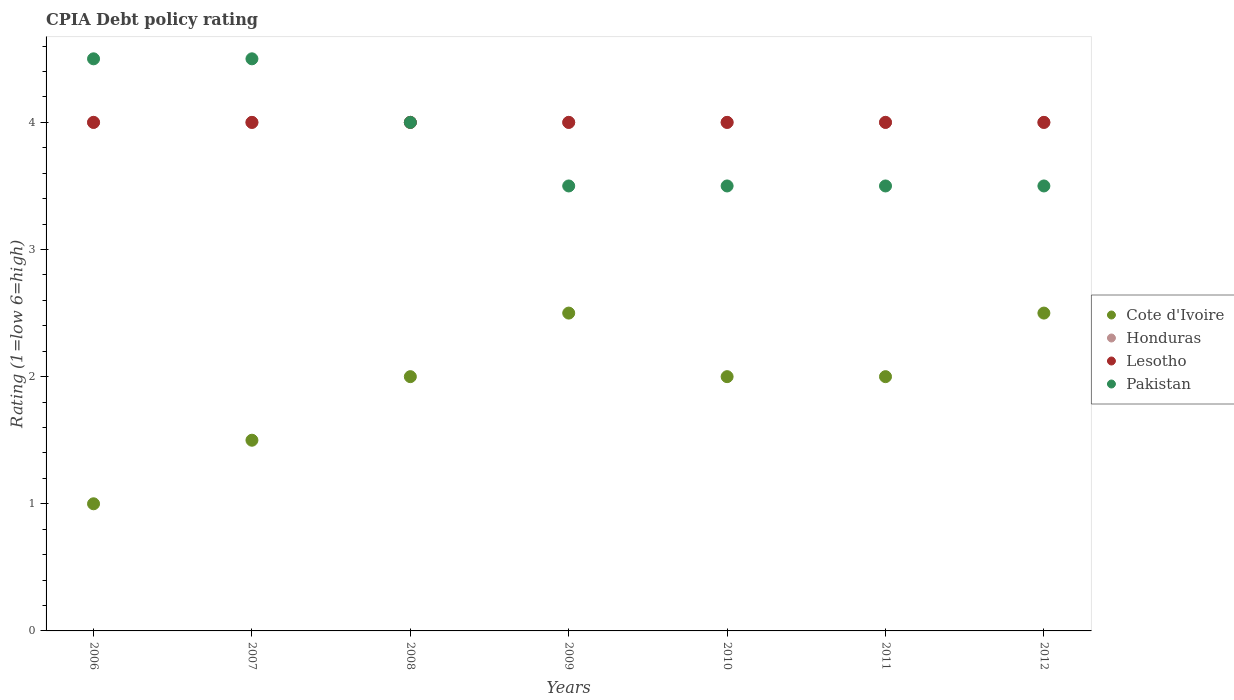What is the CPIA rating in Pakistan in 2009?
Your answer should be very brief. 3.5. Across all years, what is the maximum CPIA rating in Lesotho?
Keep it short and to the point. 4. Across all years, what is the minimum CPIA rating in Lesotho?
Offer a very short reply. 4. In which year was the CPIA rating in Pakistan minimum?
Give a very brief answer. 2009. What is the total CPIA rating in Honduras in the graph?
Your answer should be compact. 28. What is the difference between the CPIA rating in Lesotho in 2009 and that in 2010?
Offer a very short reply. 0. What is the difference between the CPIA rating in Cote d'Ivoire in 2010 and the CPIA rating in Pakistan in 2007?
Offer a terse response. -2.5. In the year 2007, what is the difference between the CPIA rating in Cote d'Ivoire and CPIA rating in Pakistan?
Keep it short and to the point. -3. What is the ratio of the CPIA rating in Cote d'Ivoire in 2006 to that in 2012?
Ensure brevity in your answer.  0.4. What is the difference between the highest and the lowest CPIA rating in Honduras?
Provide a short and direct response. 0. Is it the case that in every year, the sum of the CPIA rating in Honduras and CPIA rating in Lesotho  is greater than the sum of CPIA rating in Cote d'Ivoire and CPIA rating in Pakistan?
Your answer should be very brief. No. Is it the case that in every year, the sum of the CPIA rating in Honduras and CPIA rating in Pakistan  is greater than the CPIA rating in Cote d'Ivoire?
Provide a succinct answer. Yes. Does the CPIA rating in Pakistan monotonically increase over the years?
Offer a terse response. No. Is the CPIA rating in Pakistan strictly less than the CPIA rating in Cote d'Ivoire over the years?
Keep it short and to the point. No. How many years are there in the graph?
Provide a succinct answer. 7. Does the graph contain any zero values?
Provide a short and direct response. No. How are the legend labels stacked?
Your response must be concise. Vertical. What is the title of the graph?
Provide a succinct answer. CPIA Debt policy rating. Does "Cambodia" appear as one of the legend labels in the graph?
Give a very brief answer. No. What is the label or title of the X-axis?
Ensure brevity in your answer.  Years. What is the label or title of the Y-axis?
Provide a succinct answer. Rating (1=low 6=high). What is the Rating (1=low 6=high) of Honduras in 2008?
Offer a very short reply. 4. What is the Rating (1=low 6=high) of Lesotho in 2008?
Your response must be concise. 4. What is the Rating (1=low 6=high) of Pakistan in 2008?
Your answer should be compact. 4. What is the Rating (1=low 6=high) in Cote d'Ivoire in 2009?
Your response must be concise. 2.5. What is the Rating (1=low 6=high) in Honduras in 2009?
Keep it short and to the point. 4. What is the Rating (1=low 6=high) in Pakistan in 2009?
Ensure brevity in your answer.  3.5. What is the Rating (1=low 6=high) in Cote d'Ivoire in 2010?
Provide a succinct answer. 2. What is the Rating (1=low 6=high) in Honduras in 2010?
Provide a short and direct response. 4. What is the Rating (1=low 6=high) in Pakistan in 2010?
Make the answer very short. 3.5. What is the Rating (1=low 6=high) of Cote d'Ivoire in 2011?
Offer a terse response. 2. What is the Rating (1=low 6=high) in Honduras in 2011?
Make the answer very short. 4. What is the Rating (1=low 6=high) in Lesotho in 2012?
Provide a succinct answer. 4. What is the Rating (1=low 6=high) of Pakistan in 2012?
Your answer should be compact. 3.5. Across all years, what is the maximum Rating (1=low 6=high) in Cote d'Ivoire?
Your answer should be very brief. 2.5. Across all years, what is the maximum Rating (1=low 6=high) in Pakistan?
Provide a succinct answer. 4.5. What is the total Rating (1=low 6=high) in Lesotho in the graph?
Keep it short and to the point. 28. What is the difference between the Rating (1=low 6=high) in Cote d'Ivoire in 2006 and that in 2007?
Provide a succinct answer. -0.5. What is the difference between the Rating (1=low 6=high) of Lesotho in 2006 and that in 2007?
Ensure brevity in your answer.  0. What is the difference between the Rating (1=low 6=high) of Cote d'Ivoire in 2006 and that in 2008?
Offer a terse response. -1. What is the difference between the Rating (1=low 6=high) in Honduras in 2006 and that in 2008?
Provide a succinct answer. 0. What is the difference between the Rating (1=low 6=high) in Cote d'Ivoire in 2006 and that in 2009?
Your answer should be very brief. -1.5. What is the difference between the Rating (1=low 6=high) of Honduras in 2006 and that in 2009?
Make the answer very short. 0. What is the difference between the Rating (1=low 6=high) of Lesotho in 2006 and that in 2009?
Your answer should be very brief. 0. What is the difference between the Rating (1=low 6=high) in Pakistan in 2006 and that in 2009?
Provide a succinct answer. 1. What is the difference between the Rating (1=low 6=high) of Cote d'Ivoire in 2006 and that in 2010?
Your answer should be very brief. -1. What is the difference between the Rating (1=low 6=high) of Honduras in 2006 and that in 2010?
Provide a succinct answer. 0. What is the difference between the Rating (1=low 6=high) of Lesotho in 2006 and that in 2010?
Give a very brief answer. 0. What is the difference between the Rating (1=low 6=high) of Pakistan in 2006 and that in 2010?
Ensure brevity in your answer.  1. What is the difference between the Rating (1=low 6=high) of Lesotho in 2006 and that in 2011?
Provide a short and direct response. 0. What is the difference between the Rating (1=low 6=high) of Honduras in 2006 and that in 2012?
Offer a terse response. 0. What is the difference between the Rating (1=low 6=high) of Pakistan in 2006 and that in 2012?
Offer a very short reply. 1. What is the difference between the Rating (1=low 6=high) of Cote d'Ivoire in 2007 and that in 2008?
Provide a succinct answer. -0.5. What is the difference between the Rating (1=low 6=high) of Honduras in 2007 and that in 2009?
Your answer should be compact. 0. What is the difference between the Rating (1=low 6=high) in Pakistan in 2007 and that in 2010?
Give a very brief answer. 1. What is the difference between the Rating (1=low 6=high) in Pakistan in 2007 and that in 2011?
Keep it short and to the point. 1. What is the difference between the Rating (1=low 6=high) in Honduras in 2007 and that in 2012?
Give a very brief answer. 0. What is the difference between the Rating (1=low 6=high) in Lesotho in 2007 and that in 2012?
Give a very brief answer. 0. What is the difference between the Rating (1=low 6=high) in Pakistan in 2007 and that in 2012?
Make the answer very short. 1. What is the difference between the Rating (1=low 6=high) of Honduras in 2008 and that in 2009?
Provide a succinct answer. 0. What is the difference between the Rating (1=low 6=high) of Lesotho in 2008 and that in 2009?
Give a very brief answer. 0. What is the difference between the Rating (1=low 6=high) of Pakistan in 2008 and that in 2009?
Offer a very short reply. 0.5. What is the difference between the Rating (1=low 6=high) of Cote d'Ivoire in 2008 and that in 2010?
Provide a short and direct response. 0. What is the difference between the Rating (1=low 6=high) of Honduras in 2008 and that in 2010?
Your answer should be compact. 0. What is the difference between the Rating (1=low 6=high) of Lesotho in 2008 and that in 2011?
Make the answer very short. 0. What is the difference between the Rating (1=low 6=high) of Cote d'Ivoire in 2008 and that in 2012?
Give a very brief answer. -0.5. What is the difference between the Rating (1=low 6=high) of Lesotho in 2008 and that in 2012?
Provide a short and direct response. 0. What is the difference between the Rating (1=low 6=high) in Cote d'Ivoire in 2009 and that in 2010?
Ensure brevity in your answer.  0.5. What is the difference between the Rating (1=low 6=high) in Lesotho in 2009 and that in 2011?
Provide a succinct answer. 0. What is the difference between the Rating (1=low 6=high) of Cote d'Ivoire in 2009 and that in 2012?
Provide a succinct answer. 0. What is the difference between the Rating (1=low 6=high) in Pakistan in 2009 and that in 2012?
Provide a succinct answer. 0. What is the difference between the Rating (1=low 6=high) of Honduras in 2010 and that in 2011?
Give a very brief answer. 0. What is the difference between the Rating (1=low 6=high) in Pakistan in 2010 and that in 2011?
Offer a very short reply. 0. What is the difference between the Rating (1=low 6=high) in Cote d'Ivoire in 2010 and that in 2012?
Offer a terse response. -0.5. What is the difference between the Rating (1=low 6=high) in Honduras in 2011 and that in 2012?
Provide a succinct answer. 0. What is the difference between the Rating (1=low 6=high) in Lesotho in 2011 and that in 2012?
Make the answer very short. 0. What is the difference between the Rating (1=low 6=high) of Cote d'Ivoire in 2006 and the Rating (1=low 6=high) of Pakistan in 2007?
Provide a short and direct response. -3.5. What is the difference between the Rating (1=low 6=high) of Lesotho in 2006 and the Rating (1=low 6=high) of Pakistan in 2007?
Your answer should be compact. -0.5. What is the difference between the Rating (1=low 6=high) in Cote d'Ivoire in 2006 and the Rating (1=low 6=high) in Honduras in 2008?
Provide a succinct answer. -3. What is the difference between the Rating (1=low 6=high) of Honduras in 2006 and the Rating (1=low 6=high) of Pakistan in 2008?
Ensure brevity in your answer.  0. What is the difference between the Rating (1=low 6=high) of Lesotho in 2006 and the Rating (1=low 6=high) of Pakistan in 2008?
Provide a short and direct response. 0. What is the difference between the Rating (1=low 6=high) of Cote d'Ivoire in 2006 and the Rating (1=low 6=high) of Honduras in 2009?
Give a very brief answer. -3. What is the difference between the Rating (1=low 6=high) in Cote d'Ivoire in 2006 and the Rating (1=low 6=high) in Pakistan in 2009?
Your answer should be very brief. -2.5. What is the difference between the Rating (1=low 6=high) of Honduras in 2006 and the Rating (1=low 6=high) of Pakistan in 2009?
Offer a very short reply. 0.5. What is the difference between the Rating (1=low 6=high) in Lesotho in 2006 and the Rating (1=low 6=high) in Pakistan in 2009?
Make the answer very short. 0.5. What is the difference between the Rating (1=low 6=high) of Cote d'Ivoire in 2006 and the Rating (1=low 6=high) of Honduras in 2010?
Your response must be concise. -3. What is the difference between the Rating (1=low 6=high) in Cote d'Ivoire in 2006 and the Rating (1=low 6=high) in Pakistan in 2010?
Your answer should be compact. -2.5. What is the difference between the Rating (1=low 6=high) of Honduras in 2006 and the Rating (1=low 6=high) of Lesotho in 2010?
Your answer should be compact. 0. What is the difference between the Rating (1=low 6=high) of Honduras in 2006 and the Rating (1=low 6=high) of Pakistan in 2010?
Your answer should be compact. 0.5. What is the difference between the Rating (1=low 6=high) of Lesotho in 2006 and the Rating (1=low 6=high) of Pakistan in 2010?
Provide a succinct answer. 0.5. What is the difference between the Rating (1=low 6=high) in Cote d'Ivoire in 2006 and the Rating (1=low 6=high) in Honduras in 2011?
Offer a terse response. -3. What is the difference between the Rating (1=low 6=high) in Honduras in 2006 and the Rating (1=low 6=high) in Lesotho in 2011?
Keep it short and to the point. 0. What is the difference between the Rating (1=low 6=high) of Honduras in 2006 and the Rating (1=low 6=high) of Pakistan in 2011?
Provide a succinct answer. 0.5. What is the difference between the Rating (1=low 6=high) of Lesotho in 2006 and the Rating (1=low 6=high) of Pakistan in 2011?
Ensure brevity in your answer.  0.5. What is the difference between the Rating (1=low 6=high) of Cote d'Ivoire in 2006 and the Rating (1=low 6=high) of Honduras in 2012?
Your response must be concise. -3. What is the difference between the Rating (1=low 6=high) in Cote d'Ivoire in 2006 and the Rating (1=low 6=high) in Lesotho in 2012?
Keep it short and to the point. -3. What is the difference between the Rating (1=low 6=high) in Honduras in 2006 and the Rating (1=low 6=high) in Lesotho in 2012?
Provide a short and direct response. 0. What is the difference between the Rating (1=low 6=high) of Honduras in 2006 and the Rating (1=low 6=high) of Pakistan in 2012?
Provide a short and direct response. 0.5. What is the difference between the Rating (1=low 6=high) of Lesotho in 2006 and the Rating (1=low 6=high) of Pakistan in 2012?
Your answer should be very brief. 0.5. What is the difference between the Rating (1=low 6=high) in Cote d'Ivoire in 2007 and the Rating (1=low 6=high) in Lesotho in 2008?
Your answer should be compact. -2.5. What is the difference between the Rating (1=low 6=high) of Honduras in 2007 and the Rating (1=low 6=high) of Lesotho in 2008?
Offer a terse response. 0. What is the difference between the Rating (1=low 6=high) of Honduras in 2007 and the Rating (1=low 6=high) of Pakistan in 2008?
Offer a very short reply. 0. What is the difference between the Rating (1=low 6=high) of Honduras in 2007 and the Rating (1=low 6=high) of Lesotho in 2009?
Provide a short and direct response. 0. What is the difference between the Rating (1=low 6=high) in Lesotho in 2007 and the Rating (1=low 6=high) in Pakistan in 2009?
Give a very brief answer. 0.5. What is the difference between the Rating (1=low 6=high) in Cote d'Ivoire in 2007 and the Rating (1=low 6=high) in Lesotho in 2010?
Your response must be concise. -2.5. What is the difference between the Rating (1=low 6=high) of Cote d'Ivoire in 2007 and the Rating (1=low 6=high) of Pakistan in 2010?
Your answer should be compact. -2. What is the difference between the Rating (1=low 6=high) of Honduras in 2007 and the Rating (1=low 6=high) of Lesotho in 2010?
Provide a short and direct response. 0. What is the difference between the Rating (1=low 6=high) of Lesotho in 2007 and the Rating (1=low 6=high) of Pakistan in 2010?
Provide a succinct answer. 0.5. What is the difference between the Rating (1=low 6=high) in Cote d'Ivoire in 2007 and the Rating (1=low 6=high) in Lesotho in 2011?
Keep it short and to the point. -2.5. What is the difference between the Rating (1=low 6=high) in Cote d'Ivoire in 2007 and the Rating (1=low 6=high) in Honduras in 2012?
Your answer should be compact. -2.5. What is the difference between the Rating (1=low 6=high) in Cote d'Ivoire in 2007 and the Rating (1=low 6=high) in Lesotho in 2012?
Your answer should be very brief. -2.5. What is the difference between the Rating (1=low 6=high) in Lesotho in 2007 and the Rating (1=low 6=high) in Pakistan in 2012?
Your answer should be compact. 0.5. What is the difference between the Rating (1=low 6=high) in Cote d'Ivoire in 2008 and the Rating (1=low 6=high) in Pakistan in 2009?
Make the answer very short. -1.5. What is the difference between the Rating (1=low 6=high) in Honduras in 2008 and the Rating (1=low 6=high) in Lesotho in 2009?
Provide a short and direct response. 0. What is the difference between the Rating (1=low 6=high) of Honduras in 2008 and the Rating (1=low 6=high) of Pakistan in 2009?
Ensure brevity in your answer.  0.5. What is the difference between the Rating (1=low 6=high) in Lesotho in 2008 and the Rating (1=low 6=high) in Pakistan in 2009?
Offer a terse response. 0.5. What is the difference between the Rating (1=low 6=high) in Cote d'Ivoire in 2008 and the Rating (1=low 6=high) in Pakistan in 2010?
Your answer should be compact. -1.5. What is the difference between the Rating (1=low 6=high) of Cote d'Ivoire in 2008 and the Rating (1=low 6=high) of Lesotho in 2011?
Offer a terse response. -2. What is the difference between the Rating (1=low 6=high) of Cote d'Ivoire in 2008 and the Rating (1=low 6=high) of Pakistan in 2011?
Provide a short and direct response. -1.5. What is the difference between the Rating (1=low 6=high) of Honduras in 2008 and the Rating (1=low 6=high) of Lesotho in 2011?
Your response must be concise. 0. What is the difference between the Rating (1=low 6=high) of Honduras in 2008 and the Rating (1=low 6=high) of Pakistan in 2011?
Your response must be concise. 0.5. What is the difference between the Rating (1=low 6=high) in Cote d'Ivoire in 2009 and the Rating (1=low 6=high) in Honduras in 2010?
Provide a short and direct response. -1.5. What is the difference between the Rating (1=low 6=high) in Cote d'Ivoire in 2009 and the Rating (1=low 6=high) in Lesotho in 2010?
Provide a short and direct response. -1.5. What is the difference between the Rating (1=low 6=high) in Cote d'Ivoire in 2009 and the Rating (1=low 6=high) in Pakistan in 2010?
Make the answer very short. -1. What is the difference between the Rating (1=low 6=high) in Honduras in 2009 and the Rating (1=low 6=high) in Lesotho in 2010?
Your answer should be compact. 0. What is the difference between the Rating (1=low 6=high) of Cote d'Ivoire in 2009 and the Rating (1=low 6=high) of Honduras in 2011?
Ensure brevity in your answer.  -1.5. What is the difference between the Rating (1=low 6=high) of Cote d'Ivoire in 2009 and the Rating (1=low 6=high) of Pakistan in 2011?
Provide a succinct answer. -1. What is the difference between the Rating (1=low 6=high) of Cote d'Ivoire in 2009 and the Rating (1=low 6=high) of Honduras in 2012?
Your answer should be compact. -1.5. What is the difference between the Rating (1=low 6=high) of Cote d'Ivoire in 2009 and the Rating (1=low 6=high) of Lesotho in 2012?
Provide a short and direct response. -1.5. What is the difference between the Rating (1=low 6=high) in Honduras in 2009 and the Rating (1=low 6=high) in Lesotho in 2012?
Offer a terse response. 0. What is the difference between the Rating (1=low 6=high) in Cote d'Ivoire in 2010 and the Rating (1=low 6=high) in Lesotho in 2011?
Your answer should be compact. -2. What is the difference between the Rating (1=low 6=high) in Cote d'Ivoire in 2010 and the Rating (1=low 6=high) in Pakistan in 2011?
Your answer should be compact. -1.5. What is the difference between the Rating (1=low 6=high) in Honduras in 2010 and the Rating (1=low 6=high) in Lesotho in 2011?
Offer a terse response. 0. What is the difference between the Rating (1=low 6=high) of Honduras in 2010 and the Rating (1=low 6=high) of Pakistan in 2011?
Give a very brief answer. 0.5. What is the difference between the Rating (1=low 6=high) of Cote d'Ivoire in 2010 and the Rating (1=low 6=high) of Honduras in 2012?
Provide a succinct answer. -2. What is the difference between the Rating (1=low 6=high) in Cote d'Ivoire in 2010 and the Rating (1=low 6=high) in Lesotho in 2012?
Ensure brevity in your answer.  -2. What is the difference between the Rating (1=low 6=high) of Cote d'Ivoire in 2010 and the Rating (1=low 6=high) of Pakistan in 2012?
Your response must be concise. -1.5. What is the difference between the Rating (1=low 6=high) of Honduras in 2010 and the Rating (1=low 6=high) of Lesotho in 2012?
Your answer should be very brief. 0. What is the difference between the Rating (1=low 6=high) in Cote d'Ivoire in 2011 and the Rating (1=low 6=high) in Lesotho in 2012?
Keep it short and to the point. -2. What is the average Rating (1=low 6=high) in Cote d'Ivoire per year?
Make the answer very short. 1.93. What is the average Rating (1=low 6=high) in Honduras per year?
Your response must be concise. 4. What is the average Rating (1=low 6=high) in Lesotho per year?
Offer a very short reply. 4. What is the average Rating (1=low 6=high) of Pakistan per year?
Offer a very short reply. 3.86. In the year 2006, what is the difference between the Rating (1=low 6=high) in Cote d'Ivoire and Rating (1=low 6=high) in Honduras?
Provide a short and direct response. -3. In the year 2006, what is the difference between the Rating (1=low 6=high) of Honduras and Rating (1=low 6=high) of Pakistan?
Your answer should be very brief. -0.5. In the year 2007, what is the difference between the Rating (1=low 6=high) of Cote d'Ivoire and Rating (1=low 6=high) of Pakistan?
Ensure brevity in your answer.  -3. In the year 2007, what is the difference between the Rating (1=low 6=high) in Honduras and Rating (1=low 6=high) in Lesotho?
Your answer should be compact. 0. In the year 2007, what is the difference between the Rating (1=low 6=high) in Lesotho and Rating (1=low 6=high) in Pakistan?
Keep it short and to the point. -0.5. In the year 2008, what is the difference between the Rating (1=low 6=high) in Cote d'Ivoire and Rating (1=low 6=high) in Honduras?
Provide a succinct answer. -2. In the year 2008, what is the difference between the Rating (1=low 6=high) of Honduras and Rating (1=low 6=high) of Lesotho?
Offer a very short reply. 0. In the year 2008, what is the difference between the Rating (1=low 6=high) in Honduras and Rating (1=low 6=high) in Pakistan?
Your answer should be very brief. 0. In the year 2009, what is the difference between the Rating (1=low 6=high) of Cote d'Ivoire and Rating (1=low 6=high) of Honduras?
Ensure brevity in your answer.  -1.5. In the year 2009, what is the difference between the Rating (1=low 6=high) in Cote d'Ivoire and Rating (1=low 6=high) in Pakistan?
Your answer should be compact. -1. In the year 2009, what is the difference between the Rating (1=low 6=high) of Lesotho and Rating (1=low 6=high) of Pakistan?
Ensure brevity in your answer.  0.5. In the year 2010, what is the difference between the Rating (1=low 6=high) in Cote d'Ivoire and Rating (1=low 6=high) in Honduras?
Offer a terse response. -2. In the year 2010, what is the difference between the Rating (1=low 6=high) in Cote d'Ivoire and Rating (1=low 6=high) in Pakistan?
Make the answer very short. -1.5. In the year 2010, what is the difference between the Rating (1=low 6=high) in Honduras and Rating (1=low 6=high) in Pakistan?
Provide a succinct answer. 0.5. In the year 2010, what is the difference between the Rating (1=low 6=high) in Lesotho and Rating (1=low 6=high) in Pakistan?
Make the answer very short. 0.5. In the year 2011, what is the difference between the Rating (1=low 6=high) in Cote d'Ivoire and Rating (1=low 6=high) in Lesotho?
Keep it short and to the point. -2. In the year 2011, what is the difference between the Rating (1=low 6=high) in Honduras and Rating (1=low 6=high) in Lesotho?
Keep it short and to the point. 0. In the year 2012, what is the difference between the Rating (1=low 6=high) of Cote d'Ivoire and Rating (1=low 6=high) of Honduras?
Your response must be concise. -1.5. In the year 2012, what is the difference between the Rating (1=low 6=high) in Cote d'Ivoire and Rating (1=low 6=high) in Lesotho?
Provide a short and direct response. -1.5. What is the ratio of the Rating (1=low 6=high) of Cote d'Ivoire in 2006 to that in 2007?
Provide a succinct answer. 0.67. What is the ratio of the Rating (1=low 6=high) of Honduras in 2006 to that in 2007?
Your answer should be very brief. 1. What is the ratio of the Rating (1=low 6=high) in Lesotho in 2006 to that in 2007?
Offer a very short reply. 1. What is the ratio of the Rating (1=low 6=high) in Honduras in 2006 to that in 2008?
Make the answer very short. 1. What is the ratio of the Rating (1=low 6=high) in Pakistan in 2006 to that in 2008?
Offer a terse response. 1.12. What is the ratio of the Rating (1=low 6=high) in Cote d'Ivoire in 2006 to that in 2009?
Give a very brief answer. 0.4. What is the ratio of the Rating (1=low 6=high) of Honduras in 2006 to that in 2009?
Your answer should be compact. 1. What is the ratio of the Rating (1=low 6=high) in Lesotho in 2006 to that in 2009?
Provide a succinct answer. 1. What is the ratio of the Rating (1=low 6=high) of Cote d'Ivoire in 2006 to that in 2010?
Your response must be concise. 0.5. What is the ratio of the Rating (1=low 6=high) in Honduras in 2006 to that in 2010?
Provide a succinct answer. 1. What is the ratio of the Rating (1=low 6=high) in Pakistan in 2006 to that in 2010?
Keep it short and to the point. 1.29. What is the ratio of the Rating (1=low 6=high) in Cote d'Ivoire in 2006 to that in 2012?
Your response must be concise. 0.4. What is the ratio of the Rating (1=low 6=high) in Cote d'Ivoire in 2007 to that in 2008?
Offer a very short reply. 0.75. What is the ratio of the Rating (1=low 6=high) of Honduras in 2007 to that in 2008?
Keep it short and to the point. 1. What is the ratio of the Rating (1=low 6=high) of Pakistan in 2007 to that in 2008?
Make the answer very short. 1.12. What is the ratio of the Rating (1=low 6=high) of Cote d'Ivoire in 2007 to that in 2009?
Give a very brief answer. 0.6. What is the ratio of the Rating (1=low 6=high) of Lesotho in 2007 to that in 2010?
Keep it short and to the point. 1. What is the ratio of the Rating (1=low 6=high) in Lesotho in 2007 to that in 2011?
Give a very brief answer. 1. What is the ratio of the Rating (1=low 6=high) in Honduras in 2007 to that in 2012?
Provide a succinct answer. 1. What is the ratio of the Rating (1=low 6=high) in Cote d'Ivoire in 2008 to that in 2009?
Provide a short and direct response. 0.8. What is the ratio of the Rating (1=low 6=high) of Cote d'Ivoire in 2008 to that in 2010?
Your answer should be compact. 1. What is the ratio of the Rating (1=low 6=high) in Honduras in 2008 to that in 2010?
Provide a succinct answer. 1. What is the ratio of the Rating (1=low 6=high) of Cote d'Ivoire in 2008 to that in 2011?
Provide a short and direct response. 1. What is the ratio of the Rating (1=low 6=high) in Lesotho in 2008 to that in 2011?
Your response must be concise. 1. What is the ratio of the Rating (1=low 6=high) in Pakistan in 2008 to that in 2011?
Give a very brief answer. 1.14. What is the ratio of the Rating (1=low 6=high) in Honduras in 2008 to that in 2012?
Provide a succinct answer. 1. What is the ratio of the Rating (1=low 6=high) in Honduras in 2009 to that in 2011?
Provide a short and direct response. 1. What is the ratio of the Rating (1=low 6=high) of Cote d'Ivoire in 2009 to that in 2012?
Keep it short and to the point. 1. What is the ratio of the Rating (1=low 6=high) in Honduras in 2009 to that in 2012?
Provide a short and direct response. 1. What is the ratio of the Rating (1=low 6=high) in Cote d'Ivoire in 2010 to that in 2011?
Provide a succinct answer. 1. What is the ratio of the Rating (1=low 6=high) of Honduras in 2010 to that in 2011?
Provide a short and direct response. 1. What is the ratio of the Rating (1=low 6=high) in Pakistan in 2010 to that in 2011?
Your answer should be very brief. 1. What is the ratio of the Rating (1=low 6=high) in Cote d'Ivoire in 2010 to that in 2012?
Offer a terse response. 0.8. What is the ratio of the Rating (1=low 6=high) in Honduras in 2010 to that in 2012?
Make the answer very short. 1. What is the ratio of the Rating (1=low 6=high) of Pakistan in 2010 to that in 2012?
Make the answer very short. 1. What is the ratio of the Rating (1=low 6=high) of Honduras in 2011 to that in 2012?
Make the answer very short. 1. What is the difference between the highest and the second highest Rating (1=low 6=high) in Pakistan?
Your response must be concise. 0. What is the difference between the highest and the lowest Rating (1=low 6=high) in Lesotho?
Make the answer very short. 0. 